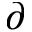Convert formula to latex. <formula><loc_0><loc_0><loc_500><loc_500>\partial</formula> 